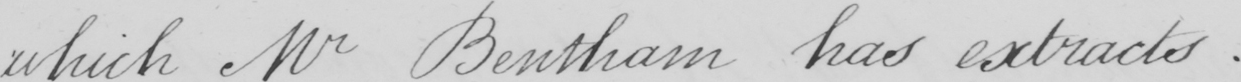Can you read and transcribe this handwriting? which Mr Bentham has extracts . 